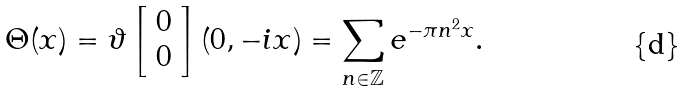Convert formula to latex. <formula><loc_0><loc_0><loc_500><loc_500>\Theta ( x ) = \vartheta \left [ \begin{array} { c } 0 \\ 0 \end{array} \right ] ( 0 , - i x ) = \sum _ { n \in \mathbb { Z } } e ^ { - \pi n ^ { 2 } x } .</formula> 